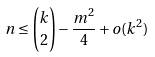<formula> <loc_0><loc_0><loc_500><loc_500>n \leq \binom { k } 2 - \frac { m ^ { 2 } } 4 + o ( k ^ { 2 } )</formula> 